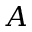<formula> <loc_0><loc_0><loc_500><loc_500>A</formula> 